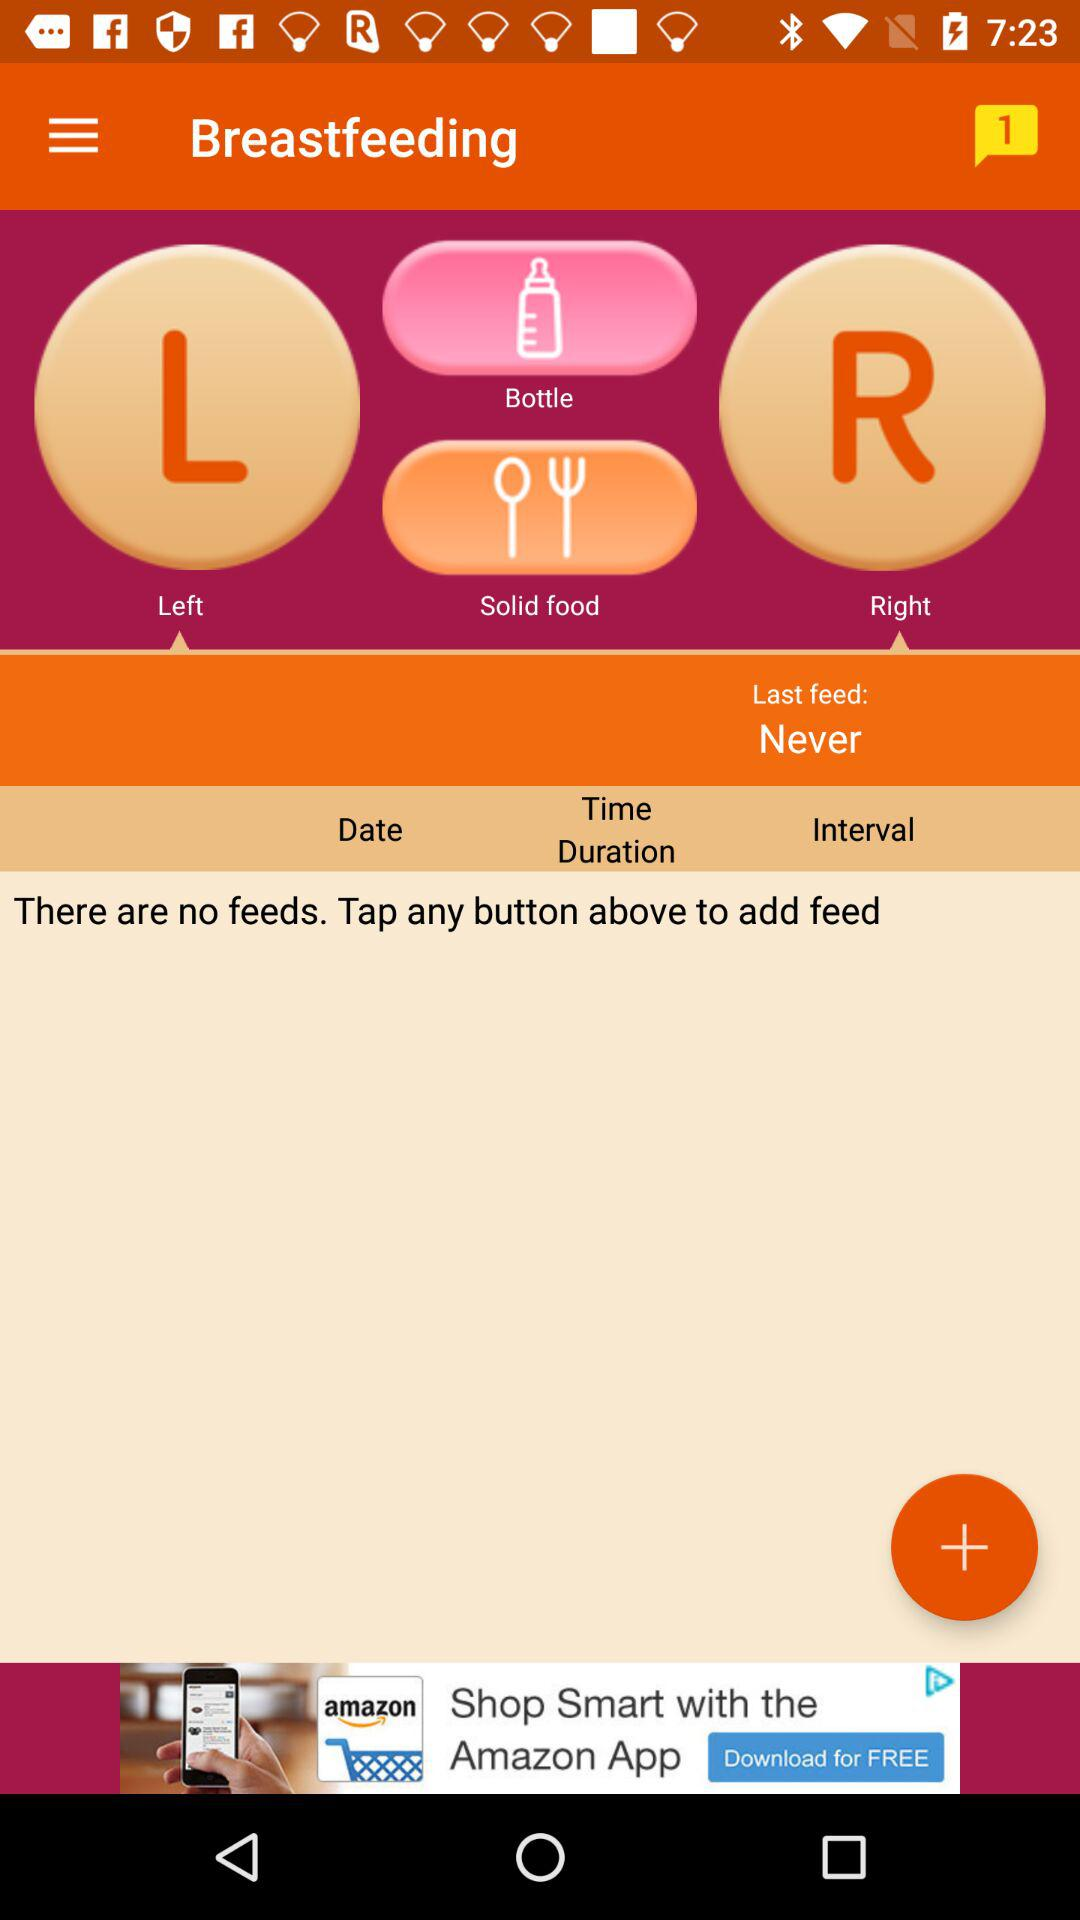When was the last feed?
When the provided information is insufficient, respond with <no answer>. <no answer> 